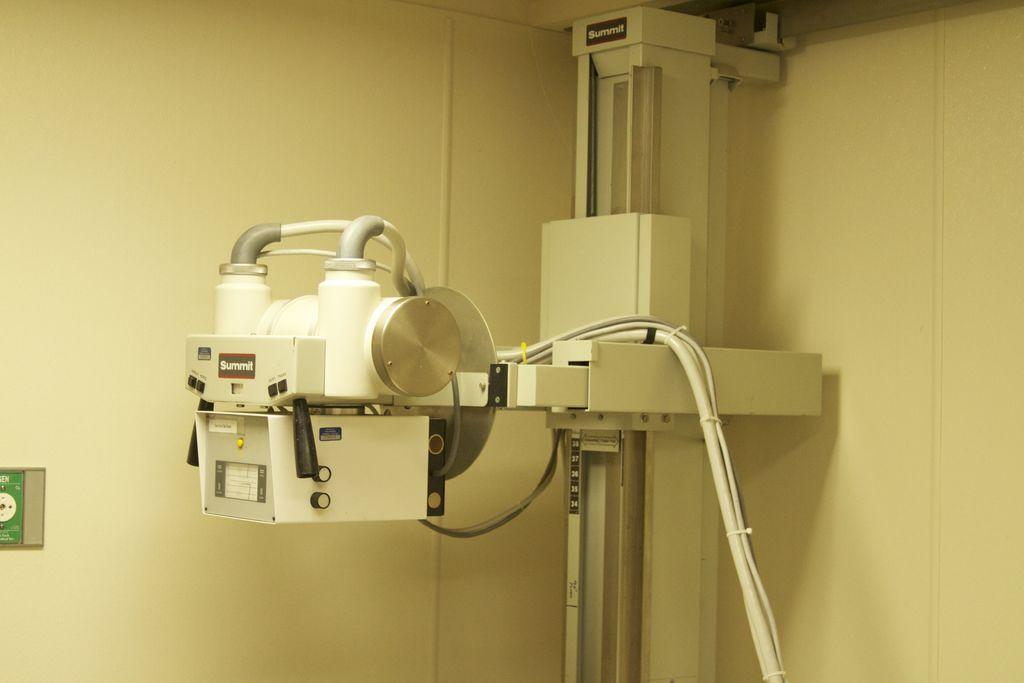What type of space is depicted in the image? The image is of a room. Are there any objects or features in the room? Yes, there is an object in the room and there are wires in the room. Can you describe the object on the wall on the left side of the image? There is an object on the wall on the left side of the image, and it has text on it. What type of feast is being prepared in the room? There is no indication of a feast or any food preparation in the image. The image only shows a room with an object, wires, and an object on the wall with text. 